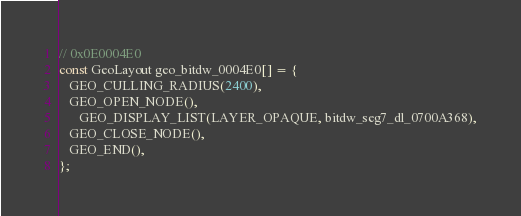<code> <loc_0><loc_0><loc_500><loc_500><_C_>// 0x0E0004E0
const GeoLayout geo_bitdw_0004E0[] = {
   GEO_CULLING_RADIUS(2400),
   GEO_OPEN_NODE(),
      GEO_DISPLAY_LIST(LAYER_OPAQUE, bitdw_seg7_dl_0700A368),
   GEO_CLOSE_NODE(),
   GEO_END(),
};
</code> 